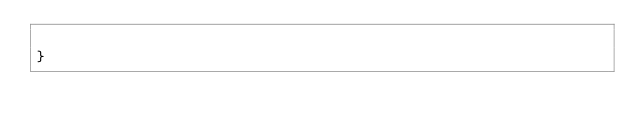Convert code to text. <code><loc_0><loc_0><loc_500><loc_500><_TypeScript_>    
}</code> 